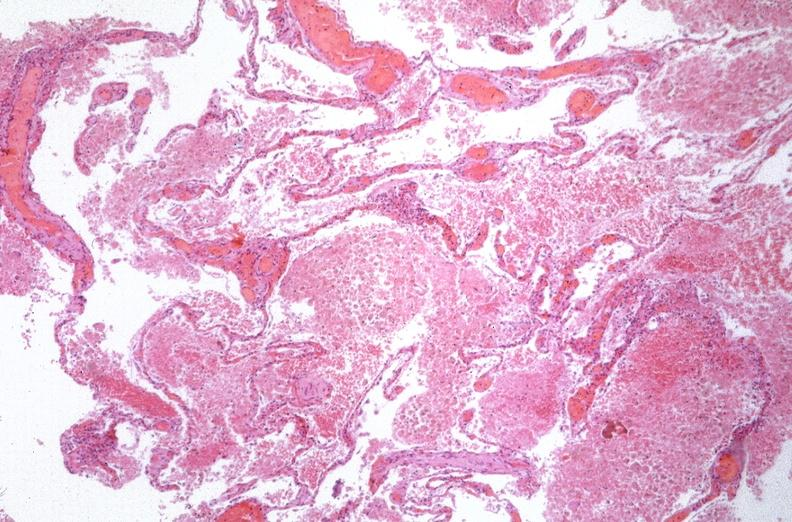how many antitrypsin does this image show lung, emphysema and pneumonia, alpha-deficiency?
Answer the question using a single word or phrase. 1 